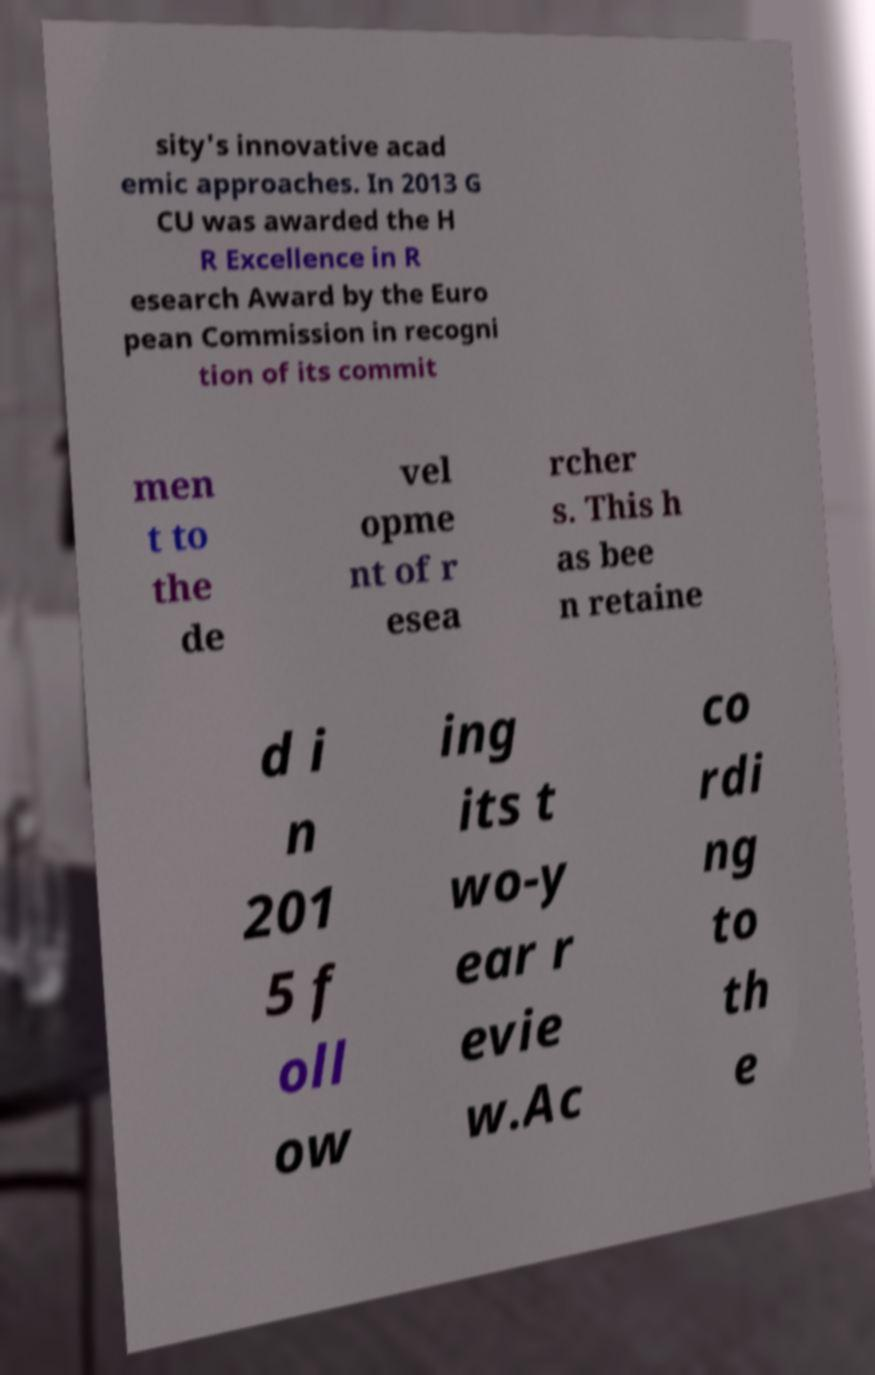Please read and relay the text visible in this image. What does it say? sity's innovative acad emic approaches. In 2013 G CU was awarded the H R Excellence in R esearch Award by the Euro pean Commission in recogni tion of its commit men t to the de vel opme nt of r esea rcher s. This h as bee n retaine d i n 201 5 f oll ow ing its t wo-y ear r evie w.Ac co rdi ng to th e 